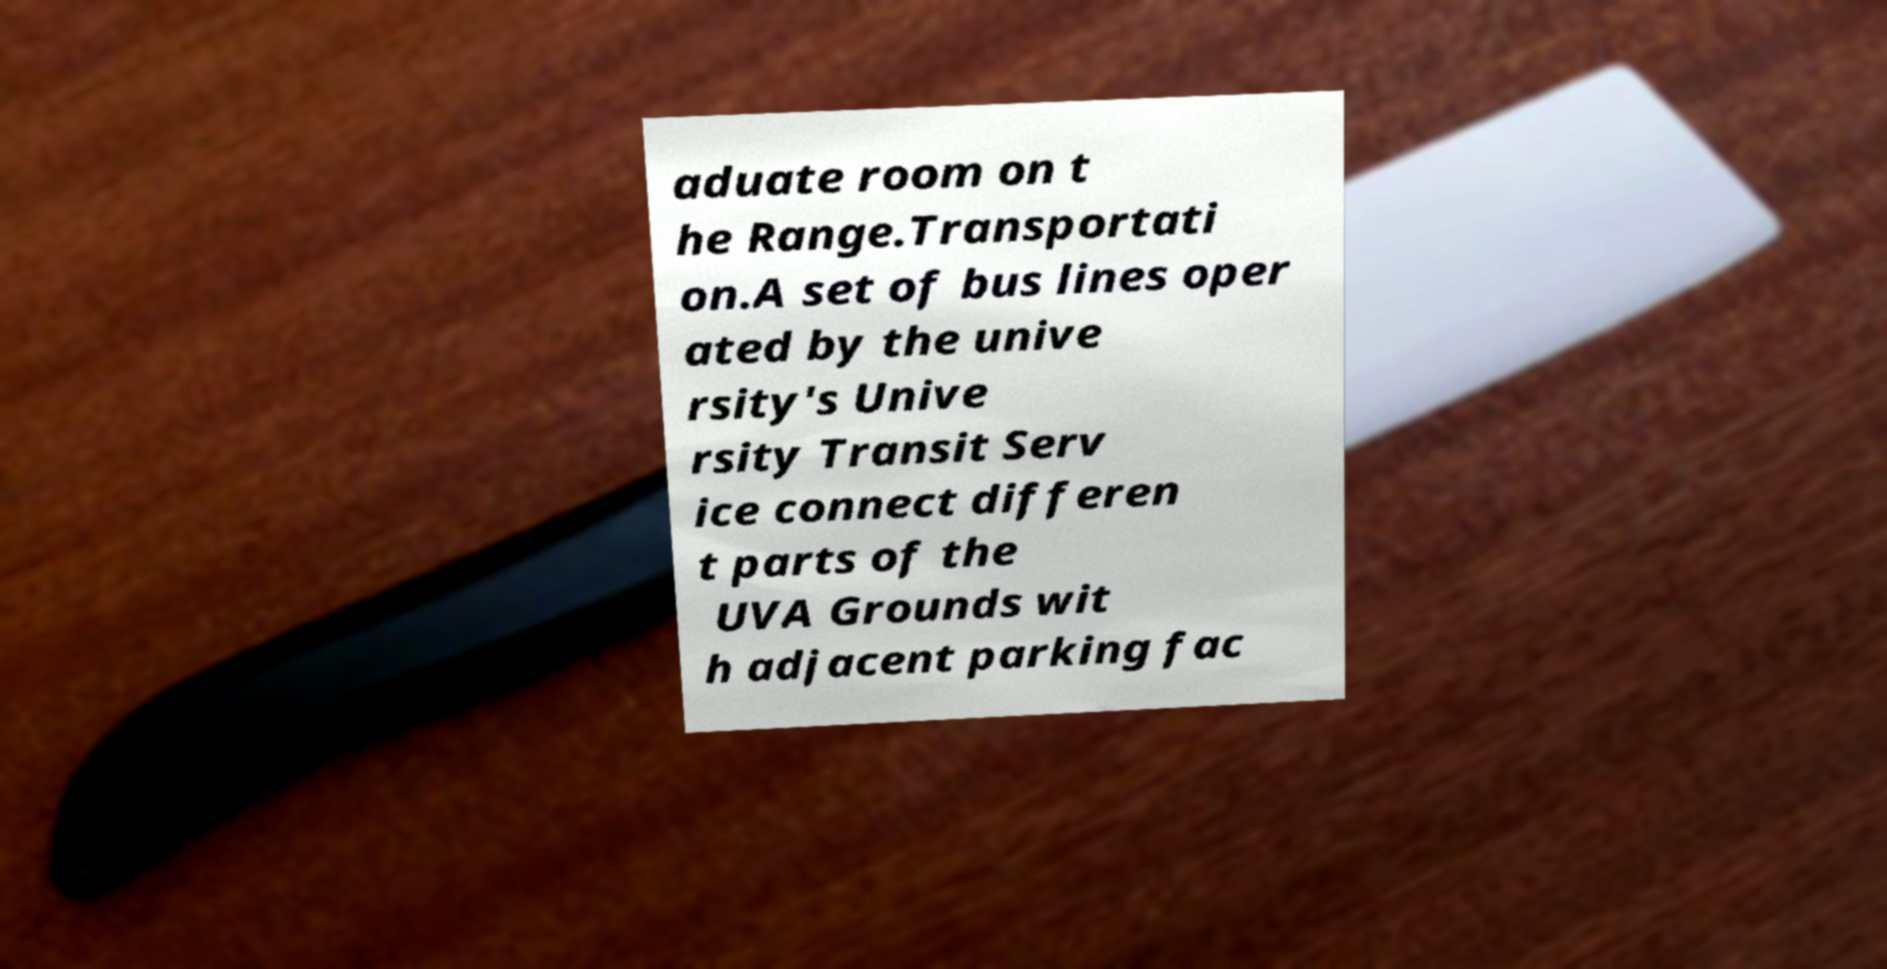Can you read and provide the text displayed in the image?This photo seems to have some interesting text. Can you extract and type it out for me? aduate room on t he Range.Transportati on.A set of bus lines oper ated by the unive rsity's Unive rsity Transit Serv ice connect differen t parts of the UVA Grounds wit h adjacent parking fac 